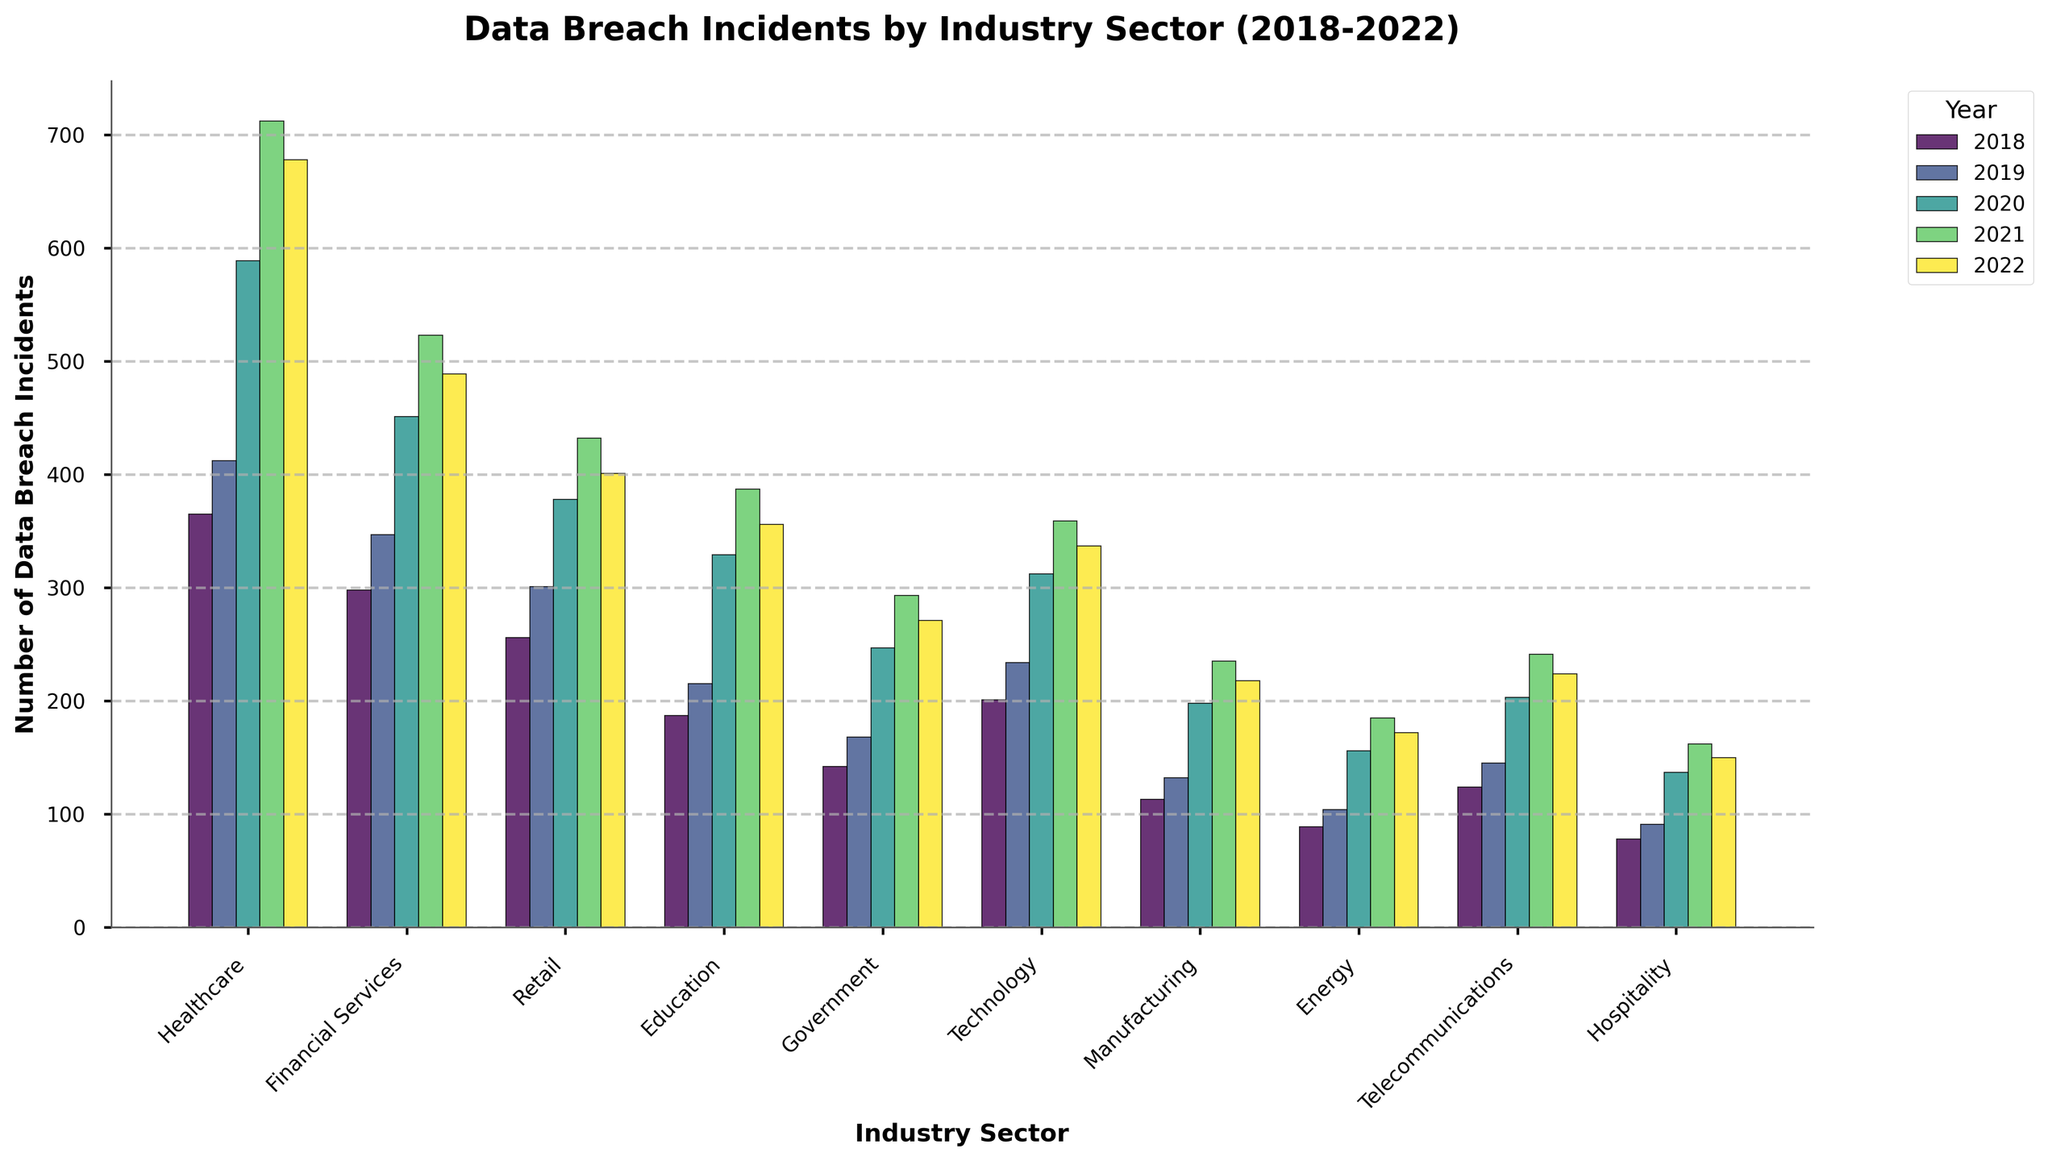Which industry sector had the highest number of data breach incidents in 2022? Look at the bar heights for all industry sectors for the year 2022. The Healthcare sector has the tallest bar, indicating it had the highest number.
Answer: Healthcare How did the number of data breach incidents in the Government sector change from 2018 to 2022? Compare the bar heights for the Government sector between 2018 and 2022. It increased from 142 in 2018 to 271 in 2022.
Answer: Increased Which two years had similar numbers of data breach incidents in the Technology sector? Look for years with bars of similar height in the Technology sector. The years 2021 and 2022 appear to be close in height, with incidents being 359 and 337 respectively.
Answer: 2021 and 2022 What is the total number of data breach incidents for the Energy sector over the 5-year period? Sum the number of incidents for each year in the Energy sector: 89 (2018) + 104 (2019) + 156 (2020) + 185 (2021) + 172 (2022) = 706.
Answer: 706 How does the average number of data breach incidents per year in the Retail sector compare to the average in the Healthcare sector? Calculate the average for Retail: (256 + 301 + 378 + 432 + 401) / 5 = 353.6. Calculate the average for Healthcare: (365 + 412 + 589 + 712 + 678) / 5 = 551.2. Compare the two averages: Healthcare's average is higher.
Answer: Healthcare's is higher Which industry saw the most significant increase in data breach incidents from 2018 to 2022? Calculate the difference in incidents for each sector: Healthcare (678-365 = 313), Financial Services (489-298 = 191), Retail (401-256 = 145), etc. The Healthcare sector saw the largest increase of 313.
Answer: Healthcare What is the difference in the number of data breach incidents between 2020 and 2022 for the Manufacturing sector? Subtract the 2020 value from the 2022 value for Manufacturing: 218 (2022) - 198 (2020) = 20.
Answer: 20 Did any industry see a decline in data breach incidents from 2021 to 2022? Compare the bar heights between 2021 and 2022 for each sector. Financial Services (523 to 489) and Healthcare (712 to 678) experienced declines.
Answer: Yes Which year had the highest total number of data breach incidents across all sectors? Sum the total number of incidents for each year across all industries and compare. For example, 2018 total = 365 + 298 + 256 + 187 + 142 + 201 + 113 + 89 + 124 + 78 = 1853. Perform similar calculations for other years.
Answer: 2021 How does the number of data breach incidents in the Telecommunications sector in 2019 compare to the Education sector in 2020? Refer to the bar heights for the specific years and sectors: Telecommunications in 2019 had 145 incidents, whereas Education in 2020 had 329 incidents.
Answer: Education in 2020 had more 